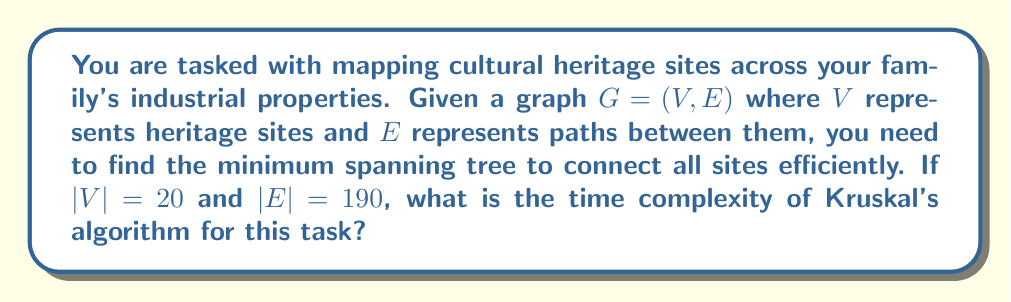Can you solve this math problem? To analyze the time complexity of Kruskal's algorithm for finding the minimum spanning tree, we need to consider the following steps:

1. Sorting the edges:
   The algorithm begins by sorting all edges in non-decreasing order of weight. With $|E| = 190$ edges, this step takes $O(|E| \log |E|)$ time using an efficient sorting algorithm like Merge Sort or Heap Sort.

2. Iterating through sorted edges:
   The algorithm then iterates through the sorted edges, which takes $O(|E|)$ time in the worst case.

3. Union-Find operations:
   For each edge, we perform Union-Find operations to check if adding the edge creates a cycle. With path compression and union by rank optimizations, each Union-Find operation takes nearly constant time, specifically $O(\alpha(|V|))$, where $\alpha$ is the inverse Ackermann function.

   The total time for Union-Find operations is $O(|E| \cdot \alpha(|V|))$.

Now, let's combine these steps:

$$T(|V|, |E|) = O(|E| \log |E| + |E| \cdot \alpha(|V|))$$

Since $\alpha(|V|)$ grows extremely slowly and is effectively constant for all practical values of $|V|$, we can simplify this to:

$$T(|V|, |E|) = O(|E| \log |E|)$$

In this case, $|E| = 190$ and $|V| = 20$. Note that $\log 190 < \log 256 = 8$, so we can say $\log |E| < 8$.

Therefore, the time complexity for this specific instance is $O(190 \log 190)$, which simplifies to $O(190 \cdot 8) = O(1520)$.

However, when expressing time complexity, we typically use the input size variables. So, the final time complexity remains $O(|E| \log |E|)$.
Answer: $O(|E| \log |E|)$ 